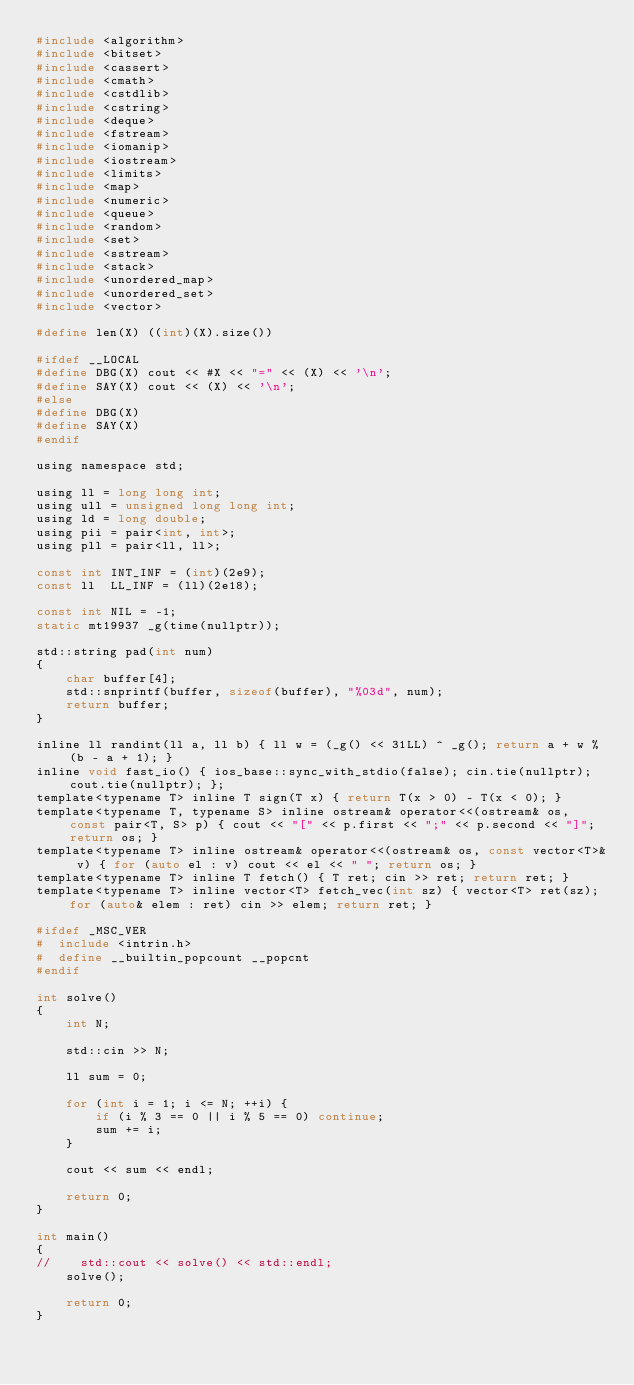Convert code to text. <code><loc_0><loc_0><loc_500><loc_500><_C_>#include <algorithm>
#include <bitset>
#include <cassert>
#include <cmath>
#include <cstdlib>
#include <cstring>
#include <deque>
#include <fstream>
#include <iomanip>
#include <iostream>
#include <limits>
#include <map>
#include <numeric>
#include <queue>
#include <random>
#include <set>
#include <sstream>
#include <stack>
#include <unordered_map>
#include <unordered_set>
#include <vector>

#define len(X) ((int)(X).size())

#ifdef __LOCAL
#define DBG(X) cout << #X << "=" << (X) << '\n';
#define SAY(X) cout << (X) << '\n';
#else
#define DBG(X)
#define SAY(X)
#endif

using namespace std;

using ll = long long int;
using ull = unsigned long long int;
using ld = long double;
using pii = pair<int, int>;
using pll = pair<ll, ll>;

const int INT_INF = (int)(2e9);
const ll  LL_INF = (ll)(2e18);

const int NIL = -1;
static mt19937 _g(time(nullptr));

std::string pad(int num)
{
    char buffer[4];
    std::snprintf(buffer, sizeof(buffer), "%03d", num);
    return buffer;
}

inline ll randint(ll a, ll b) { ll w = (_g() << 31LL) ^ _g(); return a + w % (b - a + 1); }
inline void fast_io() { ios_base::sync_with_stdio(false); cin.tie(nullptr); cout.tie(nullptr); };
template<typename T> inline T sign(T x) { return T(x > 0) - T(x < 0); }
template<typename T, typename S> inline ostream& operator<<(ostream& os, const pair<T, S> p) { cout << "[" << p.first << ";" << p.second << "]"; return os; }
template<typename T> inline ostream& operator<<(ostream& os, const vector<T>& v) { for (auto el : v) cout << el << " "; return os; }
template<typename T> inline T fetch() { T ret; cin >> ret; return ret; }
template<typename T> inline vector<T> fetch_vec(int sz) { vector<T> ret(sz); for (auto& elem : ret) cin >> elem; return ret; }

#ifdef _MSC_VER
#  include <intrin.h>
#  define __builtin_popcount __popcnt
#endif

int solve()
{
    int N;

    std::cin >> N;

    ll sum = 0;

    for (int i = 1; i <= N; ++i) {
        if (i % 3 == 0 || i % 5 == 0) continue;
        sum += i;
    }

    cout << sum << endl;

    return 0;
}

int main()
{
//    std::cout << solve() << std::endl;
    solve();

    return 0;
}</code> 